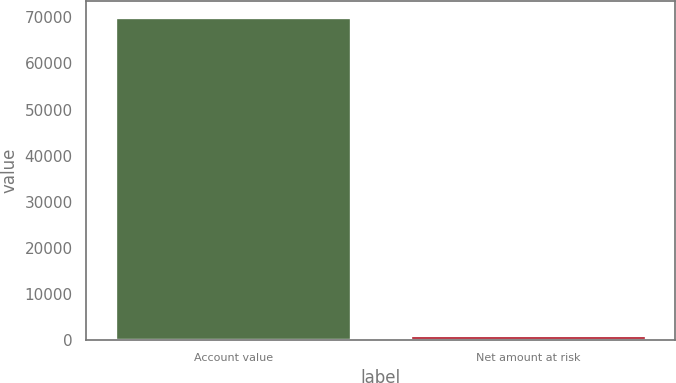Convert chart to OTSL. <chart><loc_0><loc_0><loc_500><loc_500><bar_chart><fcel>Account value<fcel>Net amount at risk<nl><fcel>69982<fcel>1132<nl></chart> 